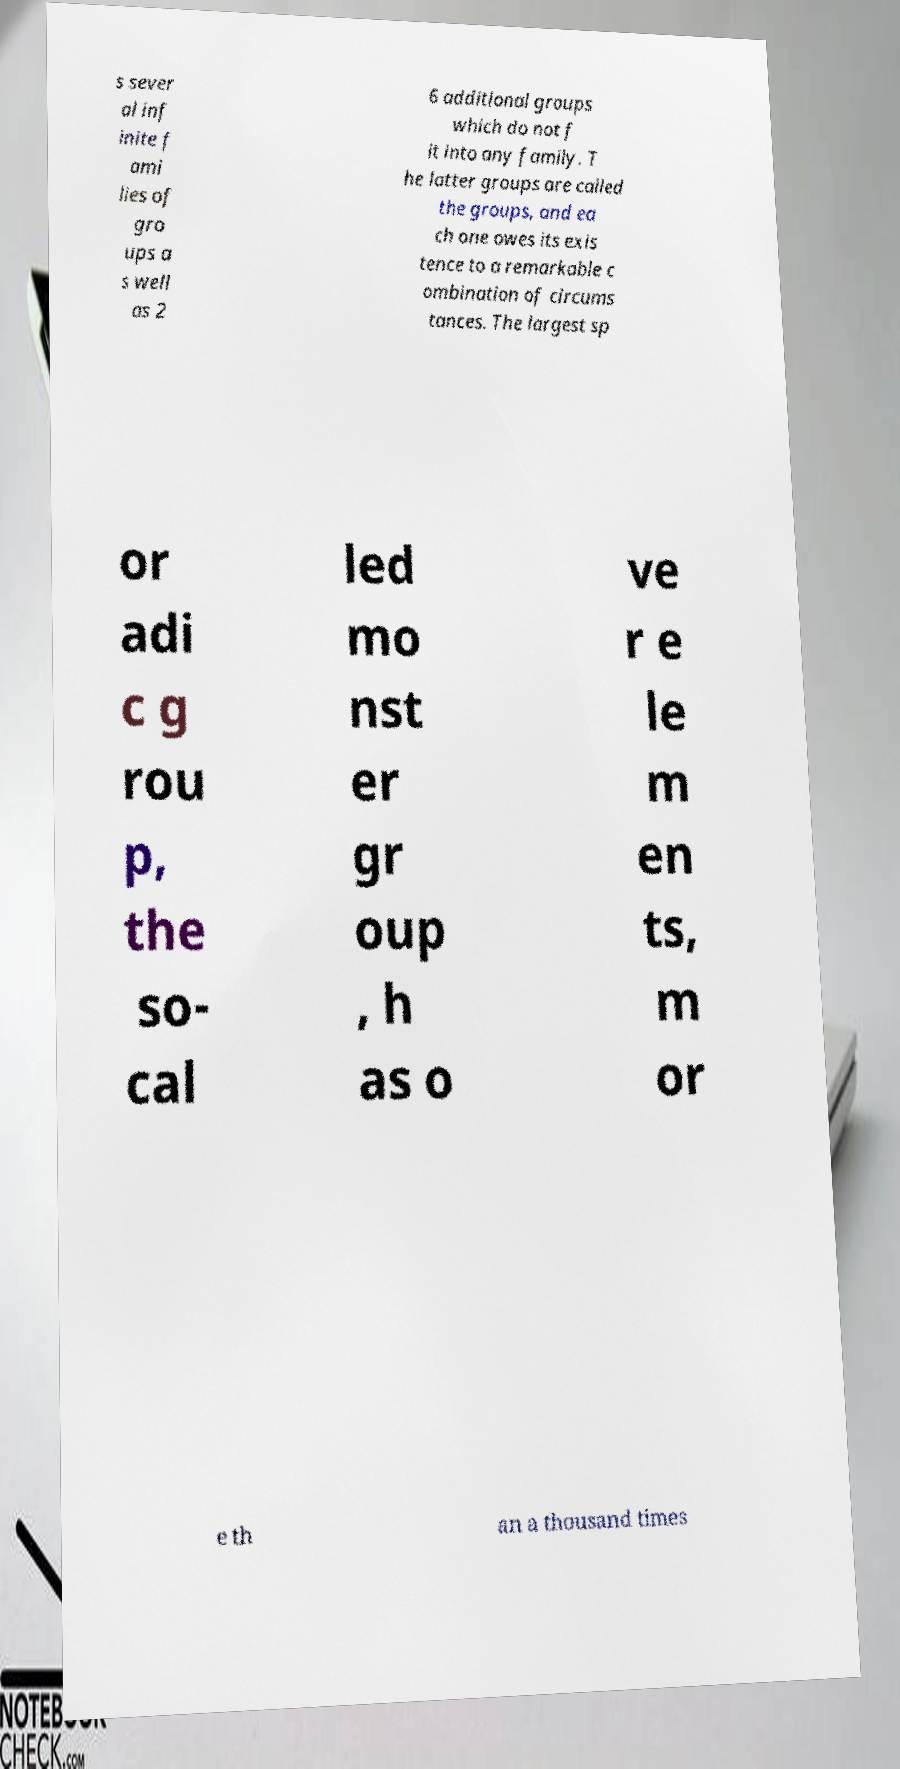For documentation purposes, I need the text within this image transcribed. Could you provide that? s sever al inf inite f ami lies of gro ups a s well as 2 6 additional groups which do not f it into any family. T he latter groups are called the groups, and ea ch one owes its exis tence to a remarkable c ombination of circums tances. The largest sp or adi c g rou p, the so- cal led mo nst er gr oup , h as o ve r e le m en ts, m or e th an a thousand times 